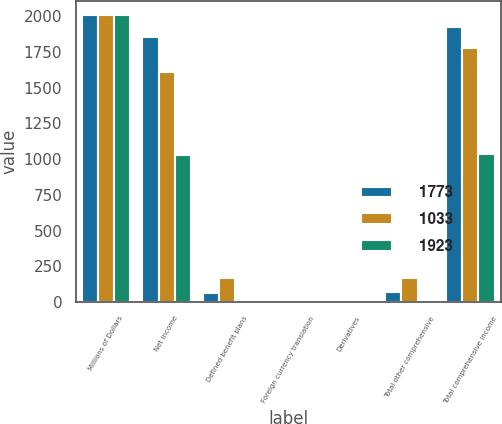<chart> <loc_0><loc_0><loc_500><loc_500><stacked_bar_chart><ecel><fcel>Millions of Dollars<fcel>Net income<fcel>Defined benefit plans<fcel>Foreign currency translation<fcel>Derivatives<fcel>Total other comprehensive<fcel>Total comprehensive income<nl><fcel>1773<fcel>2007<fcel>1855<fcel>65<fcel>2<fcel>1<fcel>68<fcel>1923<nl><fcel>1033<fcel>2006<fcel>1606<fcel>170<fcel>4<fcel>1<fcel>167<fcel>1773<nl><fcel>1923<fcel>2005<fcel>1026<fcel>1<fcel>5<fcel>1<fcel>7<fcel>1033<nl></chart> 